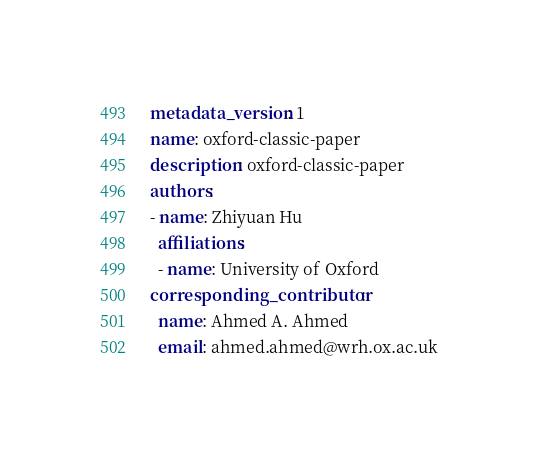Convert code to text. <code><loc_0><loc_0><loc_500><loc_500><_YAML_>metadata_version: 1
name: oxford-classic-paper
description: oxford-classic-paper
authors:
- name: Zhiyuan Hu
  affiliations:
  - name: University of Oxford
corresponding_contributor:
  name: Ahmed A. Ahmed
  email: ahmed.ahmed@wrh.ox.ac.uk
</code> 